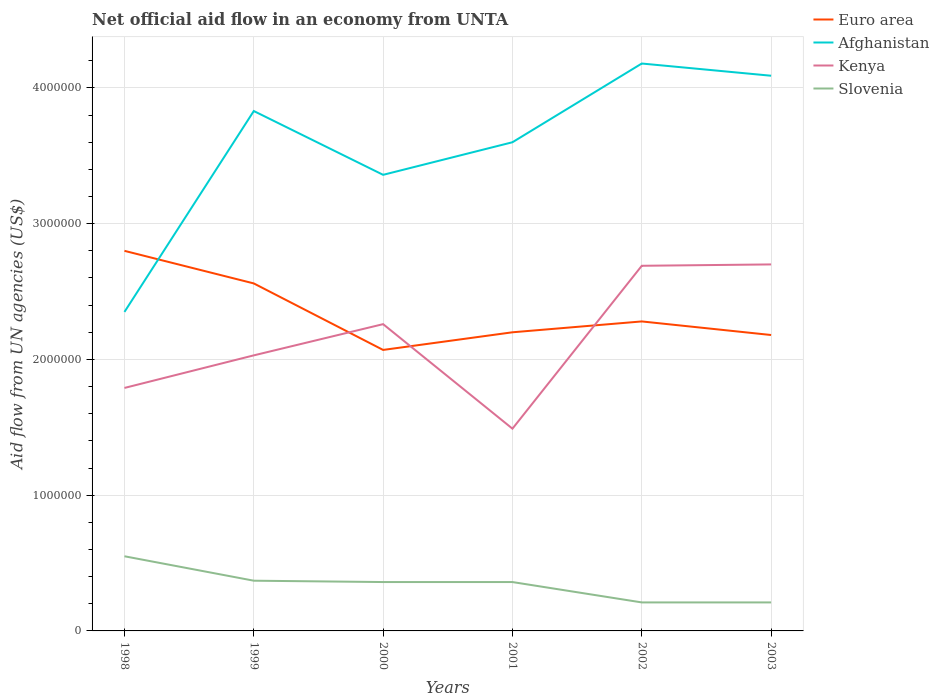How many different coloured lines are there?
Offer a terse response. 4. Is the number of lines equal to the number of legend labels?
Your answer should be very brief. Yes. Across all years, what is the maximum net official aid flow in Afghanistan?
Your answer should be compact. 2.35e+06. In which year was the net official aid flow in Afghanistan maximum?
Offer a very short reply. 1998. What is the difference between the highest and the second highest net official aid flow in Euro area?
Your answer should be compact. 7.30e+05. What is the difference between the highest and the lowest net official aid flow in Slovenia?
Your answer should be compact. 4. How many lines are there?
Make the answer very short. 4. What is the difference between two consecutive major ticks on the Y-axis?
Your answer should be very brief. 1.00e+06. Are the values on the major ticks of Y-axis written in scientific E-notation?
Ensure brevity in your answer.  No. Where does the legend appear in the graph?
Offer a terse response. Top right. How are the legend labels stacked?
Ensure brevity in your answer.  Vertical. What is the title of the graph?
Your response must be concise. Net official aid flow in an economy from UNTA. Does "Lesotho" appear as one of the legend labels in the graph?
Keep it short and to the point. No. What is the label or title of the X-axis?
Ensure brevity in your answer.  Years. What is the label or title of the Y-axis?
Provide a succinct answer. Aid flow from UN agencies (US$). What is the Aid flow from UN agencies (US$) in Euro area in 1998?
Keep it short and to the point. 2.80e+06. What is the Aid flow from UN agencies (US$) of Afghanistan in 1998?
Ensure brevity in your answer.  2.35e+06. What is the Aid flow from UN agencies (US$) of Kenya in 1998?
Your answer should be compact. 1.79e+06. What is the Aid flow from UN agencies (US$) of Euro area in 1999?
Ensure brevity in your answer.  2.56e+06. What is the Aid flow from UN agencies (US$) in Afghanistan in 1999?
Give a very brief answer. 3.83e+06. What is the Aid flow from UN agencies (US$) of Kenya in 1999?
Offer a terse response. 2.03e+06. What is the Aid flow from UN agencies (US$) of Euro area in 2000?
Ensure brevity in your answer.  2.07e+06. What is the Aid flow from UN agencies (US$) of Afghanistan in 2000?
Your response must be concise. 3.36e+06. What is the Aid flow from UN agencies (US$) in Kenya in 2000?
Your response must be concise. 2.26e+06. What is the Aid flow from UN agencies (US$) in Euro area in 2001?
Your answer should be compact. 2.20e+06. What is the Aid flow from UN agencies (US$) in Afghanistan in 2001?
Ensure brevity in your answer.  3.60e+06. What is the Aid flow from UN agencies (US$) of Kenya in 2001?
Offer a terse response. 1.49e+06. What is the Aid flow from UN agencies (US$) of Slovenia in 2001?
Ensure brevity in your answer.  3.60e+05. What is the Aid flow from UN agencies (US$) in Euro area in 2002?
Your answer should be very brief. 2.28e+06. What is the Aid flow from UN agencies (US$) of Afghanistan in 2002?
Ensure brevity in your answer.  4.18e+06. What is the Aid flow from UN agencies (US$) in Kenya in 2002?
Offer a terse response. 2.69e+06. What is the Aid flow from UN agencies (US$) of Slovenia in 2002?
Give a very brief answer. 2.10e+05. What is the Aid flow from UN agencies (US$) of Euro area in 2003?
Offer a terse response. 2.18e+06. What is the Aid flow from UN agencies (US$) in Afghanistan in 2003?
Your answer should be very brief. 4.09e+06. What is the Aid flow from UN agencies (US$) of Kenya in 2003?
Your answer should be very brief. 2.70e+06. Across all years, what is the maximum Aid flow from UN agencies (US$) in Euro area?
Give a very brief answer. 2.80e+06. Across all years, what is the maximum Aid flow from UN agencies (US$) of Afghanistan?
Make the answer very short. 4.18e+06. Across all years, what is the maximum Aid flow from UN agencies (US$) in Kenya?
Offer a very short reply. 2.70e+06. Across all years, what is the maximum Aid flow from UN agencies (US$) in Slovenia?
Provide a short and direct response. 5.50e+05. Across all years, what is the minimum Aid flow from UN agencies (US$) of Euro area?
Offer a very short reply. 2.07e+06. Across all years, what is the minimum Aid flow from UN agencies (US$) of Afghanistan?
Provide a short and direct response. 2.35e+06. Across all years, what is the minimum Aid flow from UN agencies (US$) in Kenya?
Provide a short and direct response. 1.49e+06. Across all years, what is the minimum Aid flow from UN agencies (US$) in Slovenia?
Your answer should be very brief. 2.10e+05. What is the total Aid flow from UN agencies (US$) in Euro area in the graph?
Your answer should be very brief. 1.41e+07. What is the total Aid flow from UN agencies (US$) in Afghanistan in the graph?
Your answer should be compact. 2.14e+07. What is the total Aid flow from UN agencies (US$) of Kenya in the graph?
Keep it short and to the point. 1.30e+07. What is the total Aid flow from UN agencies (US$) in Slovenia in the graph?
Give a very brief answer. 2.06e+06. What is the difference between the Aid flow from UN agencies (US$) of Afghanistan in 1998 and that in 1999?
Offer a terse response. -1.48e+06. What is the difference between the Aid flow from UN agencies (US$) in Euro area in 1998 and that in 2000?
Offer a terse response. 7.30e+05. What is the difference between the Aid flow from UN agencies (US$) of Afghanistan in 1998 and that in 2000?
Provide a short and direct response. -1.01e+06. What is the difference between the Aid flow from UN agencies (US$) of Kenya in 1998 and that in 2000?
Give a very brief answer. -4.70e+05. What is the difference between the Aid flow from UN agencies (US$) in Slovenia in 1998 and that in 2000?
Give a very brief answer. 1.90e+05. What is the difference between the Aid flow from UN agencies (US$) in Afghanistan in 1998 and that in 2001?
Ensure brevity in your answer.  -1.25e+06. What is the difference between the Aid flow from UN agencies (US$) in Kenya in 1998 and that in 2001?
Provide a short and direct response. 3.00e+05. What is the difference between the Aid flow from UN agencies (US$) of Slovenia in 1998 and that in 2001?
Make the answer very short. 1.90e+05. What is the difference between the Aid flow from UN agencies (US$) of Euro area in 1998 and that in 2002?
Ensure brevity in your answer.  5.20e+05. What is the difference between the Aid flow from UN agencies (US$) in Afghanistan in 1998 and that in 2002?
Provide a succinct answer. -1.83e+06. What is the difference between the Aid flow from UN agencies (US$) of Kenya in 1998 and that in 2002?
Provide a succinct answer. -9.00e+05. What is the difference between the Aid flow from UN agencies (US$) of Euro area in 1998 and that in 2003?
Offer a terse response. 6.20e+05. What is the difference between the Aid flow from UN agencies (US$) of Afghanistan in 1998 and that in 2003?
Make the answer very short. -1.74e+06. What is the difference between the Aid flow from UN agencies (US$) of Kenya in 1998 and that in 2003?
Offer a very short reply. -9.10e+05. What is the difference between the Aid flow from UN agencies (US$) of Slovenia in 1999 and that in 2000?
Keep it short and to the point. 10000. What is the difference between the Aid flow from UN agencies (US$) in Afghanistan in 1999 and that in 2001?
Offer a terse response. 2.30e+05. What is the difference between the Aid flow from UN agencies (US$) in Kenya in 1999 and that in 2001?
Provide a succinct answer. 5.40e+05. What is the difference between the Aid flow from UN agencies (US$) in Afghanistan in 1999 and that in 2002?
Provide a short and direct response. -3.50e+05. What is the difference between the Aid flow from UN agencies (US$) in Kenya in 1999 and that in 2002?
Keep it short and to the point. -6.60e+05. What is the difference between the Aid flow from UN agencies (US$) in Slovenia in 1999 and that in 2002?
Offer a very short reply. 1.60e+05. What is the difference between the Aid flow from UN agencies (US$) of Euro area in 1999 and that in 2003?
Your answer should be very brief. 3.80e+05. What is the difference between the Aid flow from UN agencies (US$) of Afghanistan in 1999 and that in 2003?
Ensure brevity in your answer.  -2.60e+05. What is the difference between the Aid flow from UN agencies (US$) in Kenya in 1999 and that in 2003?
Ensure brevity in your answer.  -6.70e+05. What is the difference between the Aid flow from UN agencies (US$) in Slovenia in 1999 and that in 2003?
Your answer should be compact. 1.60e+05. What is the difference between the Aid flow from UN agencies (US$) of Afghanistan in 2000 and that in 2001?
Provide a succinct answer. -2.40e+05. What is the difference between the Aid flow from UN agencies (US$) of Kenya in 2000 and that in 2001?
Make the answer very short. 7.70e+05. What is the difference between the Aid flow from UN agencies (US$) in Afghanistan in 2000 and that in 2002?
Provide a short and direct response. -8.20e+05. What is the difference between the Aid flow from UN agencies (US$) of Kenya in 2000 and that in 2002?
Your answer should be very brief. -4.30e+05. What is the difference between the Aid flow from UN agencies (US$) of Slovenia in 2000 and that in 2002?
Your answer should be compact. 1.50e+05. What is the difference between the Aid flow from UN agencies (US$) in Euro area in 2000 and that in 2003?
Provide a succinct answer. -1.10e+05. What is the difference between the Aid flow from UN agencies (US$) of Afghanistan in 2000 and that in 2003?
Ensure brevity in your answer.  -7.30e+05. What is the difference between the Aid flow from UN agencies (US$) in Kenya in 2000 and that in 2003?
Provide a succinct answer. -4.40e+05. What is the difference between the Aid flow from UN agencies (US$) of Slovenia in 2000 and that in 2003?
Keep it short and to the point. 1.50e+05. What is the difference between the Aid flow from UN agencies (US$) in Afghanistan in 2001 and that in 2002?
Provide a short and direct response. -5.80e+05. What is the difference between the Aid flow from UN agencies (US$) in Kenya in 2001 and that in 2002?
Your answer should be compact. -1.20e+06. What is the difference between the Aid flow from UN agencies (US$) in Slovenia in 2001 and that in 2002?
Keep it short and to the point. 1.50e+05. What is the difference between the Aid flow from UN agencies (US$) in Euro area in 2001 and that in 2003?
Your answer should be very brief. 2.00e+04. What is the difference between the Aid flow from UN agencies (US$) of Afghanistan in 2001 and that in 2003?
Your answer should be compact. -4.90e+05. What is the difference between the Aid flow from UN agencies (US$) of Kenya in 2001 and that in 2003?
Give a very brief answer. -1.21e+06. What is the difference between the Aid flow from UN agencies (US$) in Slovenia in 2002 and that in 2003?
Your response must be concise. 0. What is the difference between the Aid flow from UN agencies (US$) in Euro area in 1998 and the Aid flow from UN agencies (US$) in Afghanistan in 1999?
Your response must be concise. -1.03e+06. What is the difference between the Aid flow from UN agencies (US$) in Euro area in 1998 and the Aid flow from UN agencies (US$) in Kenya in 1999?
Ensure brevity in your answer.  7.70e+05. What is the difference between the Aid flow from UN agencies (US$) of Euro area in 1998 and the Aid flow from UN agencies (US$) of Slovenia in 1999?
Offer a very short reply. 2.43e+06. What is the difference between the Aid flow from UN agencies (US$) of Afghanistan in 1998 and the Aid flow from UN agencies (US$) of Kenya in 1999?
Give a very brief answer. 3.20e+05. What is the difference between the Aid flow from UN agencies (US$) in Afghanistan in 1998 and the Aid flow from UN agencies (US$) in Slovenia in 1999?
Your answer should be compact. 1.98e+06. What is the difference between the Aid flow from UN agencies (US$) of Kenya in 1998 and the Aid flow from UN agencies (US$) of Slovenia in 1999?
Make the answer very short. 1.42e+06. What is the difference between the Aid flow from UN agencies (US$) of Euro area in 1998 and the Aid flow from UN agencies (US$) of Afghanistan in 2000?
Your answer should be compact. -5.60e+05. What is the difference between the Aid flow from UN agencies (US$) in Euro area in 1998 and the Aid flow from UN agencies (US$) in Kenya in 2000?
Provide a succinct answer. 5.40e+05. What is the difference between the Aid flow from UN agencies (US$) in Euro area in 1998 and the Aid flow from UN agencies (US$) in Slovenia in 2000?
Provide a succinct answer. 2.44e+06. What is the difference between the Aid flow from UN agencies (US$) in Afghanistan in 1998 and the Aid flow from UN agencies (US$) in Slovenia in 2000?
Provide a succinct answer. 1.99e+06. What is the difference between the Aid flow from UN agencies (US$) of Kenya in 1998 and the Aid flow from UN agencies (US$) of Slovenia in 2000?
Your response must be concise. 1.43e+06. What is the difference between the Aid flow from UN agencies (US$) in Euro area in 1998 and the Aid flow from UN agencies (US$) in Afghanistan in 2001?
Your answer should be compact. -8.00e+05. What is the difference between the Aid flow from UN agencies (US$) in Euro area in 1998 and the Aid flow from UN agencies (US$) in Kenya in 2001?
Offer a terse response. 1.31e+06. What is the difference between the Aid flow from UN agencies (US$) in Euro area in 1998 and the Aid flow from UN agencies (US$) in Slovenia in 2001?
Give a very brief answer. 2.44e+06. What is the difference between the Aid flow from UN agencies (US$) of Afghanistan in 1998 and the Aid flow from UN agencies (US$) of Kenya in 2001?
Your answer should be very brief. 8.60e+05. What is the difference between the Aid flow from UN agencies (US$) in Afghanistan in 1998 and the Aid flow from UN agencies (US$) in Slovenia in 2001?
Your answer should be compact. 1.99e+06. What is the difference between the Aid flow from UN agencies (US$) in Kenya in 1998 and the Aid flow from UN agencies (US$) in Slovenia in 2001?
Keep it short and to the point. 1.43e+06. What is the difference between the Aid flow from UN agencies (US$) of Euro area in 1998 and the Aid flow from UN agencies (US$) of Afghanistan in 2002?
Keep it short and to the point. -1.38e+06. What is the difference between the Aid flow from UN agencies (US$) of Euro area in 1998 and the Aid flow from UN agencies (US$) of Slovenia in 2002?
Ensure brevity in your answer.  2.59e+06. What is the difference between the Aid flow from UN agencies (US$) in Afghanistan in 1998 and the Aid flow from UN agencies (US$) in Kenya in 2002?
Your answer should be very brief. -3.40e+05. What is the difference between the Aid flow from UN agencies (US$) of Afghanistan in 1998 and the Aid flow from UN agencies (US$) of Slovenia in 2002?
Give a very brief answer. 2.14e+06. What is the difference between the Aid flow from UN agencies (US$) in Kenya in 1998 and the Aid flow from UN agencies (US$) in Slovenia in 2002?
Make the answer very short. 1.58e+06. What is the difference between the Aid flow from UN agencies (US$) of Euro area in 1998 and the Aid flow from UN agencies (US$) of Afghanistan in 2003?
Give a very brief answer. -1.29e+06. What is the difference between the Aid flow from UN agencies (US$) in Euro area in 1998 and the Aid flow from UN agencies (US$) in Kenya in 2003?
Ensure brevity in your answer.  1.00e+05. What is the difference between the Aid flow from UN agencies (US$) of Euro area in 1998 and the Aid flow from UN agencies (US$) of Slovenia in 2003?
Keep it short and to the point. 2.59e+06. What is the difference between the Aid flow from UN agencies (US$) of Afghanistan in 1998 and the Aid flow from UN agencies (US$) of Kenya in 2003?
Make the answer very short. -3.50e+05. What is the difference between the Aid flow from UN agencies (US$) of Afghanistan in 1998 and the Aid flow from UN agencies (US$) of Slovenia in 2003?
Offer a terse response. 2.14e+06. What is the difference between the Aid flow from UN agencies (US$) of Kenya in 1998 and the Aid flow from UN agencies (US$) of Slovenia in 2003?
Ensure brevity in your answer.  1.58e+06. What is the difference between the Aid flow from UN agencies (US$) in Euro area in 1999 and the Aid flow from UN agencies (US$) in Afghanistan in 2000?
Provide a short and direct response. -8.00e+05. What is the difference between the Aid flow from UN agencies (US$) in Euro area in 1999 and the Aid flow from UN agencies (US$) in Kenya in 2000?
Your response must be concise. 3.00e+05. What is the difference between the Aid flow from UN agencies (US$) in Euro area in 1999 and the Aid flow from UN agencies (US$) in Slovenia in 2000?
Make the answer very short. 2.20e+06. What is the difference between the Aid flow from UN agencies (US$) of Afghanistan in 1999 and the Aid flow from UN agencies (US$) of Kenya in 2000?
Offer a very short reply. 1.57e+06. What is the difference between the Aid flow from UN agencies (US$) in Afghanistan in 1999 and the Aid flow from UN agencies (US$) in Slovenia in 2000?
Ensure brevity in your answer.  3.47e+06. What is the difference between the Aid flow from UN agencies (US$) of Kenya in 1999 and the Aid flow from UN agencies (US$) of Slovenia in 2000?
Make the answer very short. 1.67e+06. What is the difference between the Aid flow from UN agencies (US$) of Euro area in 1999 and the Aid flow from UN agencies (US$) of Afghanistan in 2001?
Provide a short and direct response. -1.04e+06. What is the difference between the Aid flow from UN agencies (US$) in Euro area in 1999 and the Aid flow from UN agencies (US$) in Kenya in 2001?
Your response must be concise. 1.07e+06. What is the difference between the Aid flow from UN agencies (US$) of Euro area in 1999 and the Aid flow from UN agencies (US$) of Slovenia in 2001?
Your answer should be compact. 2.20e+06. What is the difference between the Aid flow from UN agencies (US$) of Afghanistan in 1999 and the Aid flow from UN agencies (US$) of Kenya in 2001?
Your answer should be compact. 2.34e+06. What is the difference between the Aid flow from UN agencies (US$) of Afghanistan in 1999 and the Aid flow from UN agencies (US$) of Slovenia in 2001?
Make the answer very short. 3.47e+06. What is the difference between the Aid flow from UN agencies (US$) of Kenya in 1999 and the Aid flow from UN agencies (US$) of Slovenia in 2001?
Provide a succinct answer. 1.67e+06. What is the difference between the Aid flow from UN agencies (US$) in Euro area in 1999 and the Aid flow from UN agencies (US$) in Afghanistan in 2002?
Your response must be concise. -1.62e+06. What is the difference between the Aid flow from UN agencies (US$) in Euro area in 1999 and the Aid flow from UN agencies (US$) in Kenya in 2002?
Give a very brief answer. -1.30e+05. What is the difference between the Aid flow from UN agencies (US$) in Euro area in 1999 and the Aid flow from UN agencies (US$) in Slovenia in 2002?
Make the answer very short. 2.35e+06. What is the difference between the Aid flow from UN agencies (US$) of Afghanistan in 1999 and the Aid flow from UN agencies (US$) of Kenya in 2002?
Make the answer very short. 1.14e+06. What is the difference between the Aid flow from UN agencies (US$) in Afghanistan in 1999 and the Aid flow from UN agencies (US$) in Slovenia in 2002?
Provide a succinct answer. 3.62e+06. What is the difference between the Aid flow from UN agencies (US$) in Kenya in 1999 and the Aid flow from UN agencies (US$) in Slovenia in 2002?
Your response must be concise. 1.82e+06. What is the difference between the Aid flow from UN agencies (US$) in Euro area in 1999 and the Aid flow from UN agencies (US$) in Afghanistan in 2003?
Your response must be concise. -1.53e+06. What is the difference between the Aid flow from UN agencies (US$) in Euro area in 1999 and the Aid flow from UN agencies (US$) in Slovenia in 2003?
Give a very brief answer. 2.35e+06. What is the difference between the Aid flow from UN agencies (US$) in Afghanistan in 1999 and the Aid flow from UN agencies (US$) in Kenya in 2003?
Offer a very short reply. 1.13e+06. What is the difference between the Aid flow from UN agencies (US$) of Afghanistan in 1999 and the Aid flow from UN agencies (US$) of Slovenia in 2003?
Offer a terse response. 3.62e+06. What is the difference between the Aid flow from UN agencies (US$) in Kenya in 1999 and the Aid flow from UN agencies (US$) in Slovenia in 2003?
Make the answer very short. 1.82e+06. What is the difference between the Aid flow from UN agencies (US$) in Euro area in 2000 and the Aid flow from UN agencies (US$) in Afghanistan in 2001?
Keep it short and to the point. -1.53e+06. What is the difference between the Aid flow from UN agencies (US$) in Euro area in 2000 and the Aid flow from UN agencies (US$) in Kenya in 2001?
Your answer should be compact. 5.80e+05. What is the difference between the Aid flow from UN agencies (US$) of Euro area in 2000 and the Aid flow from UN agencies (US$) of Slovenia in 2001?
Offer a terse response. 1.71e+06. What is the difference between the Aid flow from UN agencies (US$) of Afghanistan in 2000 and the Aid flow from UN agencies (US$) of Kenya in 2001?
Provide a succinct answer. 1.87e+06. What is the difference between the Aid flow from UN agencies (US$) in Kenya in 2000 and the Aid flow from UN agencies (US$) in Slovenia in 2001?
Make the answer very short. 1.90e+06. What is the difference between the Aid flow from UN agencies (US$) in Euro area in 2000 and the Aid flow from UN agencies (US$) in Afghanistan in 2002?
Ensure brevity in your answer.  -2.11e+06. What is the difference between the Aid flow from UN agencies (US$) in Euro area in 2000 and the Aid flow from UN agencies (US$) in Kenya in 2002?
Your response must be concise. -6.20e+05. What is the difference between the Aid flow from UN agencies (US$) in Euro area in 2000 and the Aid flow from UN agencies (US$) in Slovenia in 2002?
Your answer should be very brief. 1.86e+06. What is the difference between the Aid flow from UN agencies (US$) of Afghanistan in 2000 and the Aid flow from UN agencies (US$) of Kenya in 2002?
Make the answer very short. 6.70e+05. What is the difference between the Aid flow from UN agencies (US$) of Afghanistan in 2000 and the Aid flow from UN agencies (US$) of Slovenia in 2002?
Make the answer very short. 3.15e+06. What is the difference between the Aid flow from UN agencies (US$) in Kenya in 2000 and the Aid flow from UN agencies (US$) in Slovenia in 2002?
Make the answer very short. 2.05e+06. What is the difference between the Aid flow from UN agencies (US$) of Euro area in 2000 and the Aid flow from UN agencies (US$) of Afghanistan in 2003?
Provide a short and direct response. -2.02e+06. What is the difference between the Aid flow from UN agencies (US$) in Euro area in 2000 and the Aid flow from UN agencies (US$) in Kenya in 2003?
Offer a terse response. -6.30e+05. What is the difference between the Aid flow from UN agencies (US$) in Euro area in 2000 and the Aid flow from UN agencies (US$) in Slovenia in 2003?
Keep it short and to the point. 1.86e+06. What is the difference between the Aid flow from UN agencies (US$) in Afghanistan in 2000 and the Aid flow from UN agencies (US$) in Kenya in 2003?
Give a very brief answer. 6.60e+05. What is the difference between the Aid flow from UN agencies (US$) in Afghanistan in 2000 and the Aid flow from UN agencies (US$) in Slovenia in 2003?
Your response must be concise. 3.15e+06. What is the difference between the Aid flow from UN agencies (US$) in Kenya in 2000 and the Aid flow from UN agencies (US$) in Slovenia in 2003?
Give a very brief answer. 2.05e+06. What is the difference between the Aid flow from UN agencies (US$) in Euro area in 2001 and the Aid flow from UN agencies (US$) in Afghanistan in 2002?
Ensure brevity in your answer.  -1.98e+06. What is the difference between the Aid flow from UN agencies (US$) of Euro area in 2001 and the Aid flow from UN agencies (US$) of Kenya in 2002?
Your answer should be compact. -4.90e+05. What is the difference between the Aid flow from UN agencies (US$) in Euro area in 2001 and the Aid flow from UN agencies (US$) in Slovenia in 2002?
Provide a short and direct response. 1.99e+06. What is the difference between the Aid flow from UN agencies (US$) in Afghanistan in 2001 and the Aid flow from UN agencies (US$) in Kenya in 2002?
Your response must be concise. 9.10e+05. What is the difference between the Aid flow from UN agencies (US$) in Afghanistan in 2001 and the Aid flow from UN agencies (US$) in Slovenia in 2002?
Give a very brief answer. 3.39e+06. What is the difference between the Aid flow from UN agencies (US$) of Kenya in 2001 and the Aid flow from UN agencies (US$) of Slovenia in 2002?
Offer a terse response. 1.28e+06. What is the difference between the Aid flow from UN agencies (US$) in Euro area in 2001 and the Aid flow from UN agencies (US$) in Afghanistan in 2003?
Your response must be concise. -1.89e+06. What is the difference between the Aid flow from UN agencies (US$) of Euro area in 2001 and the Aid flow from UN agencies (US$) of Kenya in 2003?
Keep it short and to the point. -5.00e+05. What is the difference between the Aid flow from UN agencies (US$) of Euro area in 2001 and the Aid flow from UN agencies (US$) of Slovenia in 2003?
Offer a very short reply. 1.99e+06. What is the difference between the Aid flow from UN agencies (US$) of Afghanistan in 2001 and the Aid flow from UN agencies (US$) of Kenya in 2003?
Your answer should be very brief. 9.00e+05. What is the difference between the Aid flow from UN agencies (US$) of Afghanistan in 2001 and the Aid flow from UN agencies (US$) of Slovenia in 2003?
Your answer should be compact. 3.39e+06. What is the difference between the Aid flow from UN agencies (US$) of Kenya in 2001 and the Aid flow from UN agencies (US$) of Slovenia in 2003?
Keep it short and to the point. 1.28e+06. What is the difference between the Aid flow from UN agencies (US$) in Euro area in 2002 and the Aid flow from UN agencies (US$) in Afghanistan in 2003?
Your answer should be compact. -1.81e+06. What is the difference between the Aid flow from UN agencies (US$) in Euro area in 2002 and the Aid flow from UN agencies (US$) in Kenya in 2003?
Give a very brief answer. -4.20e+05. What is the difference between the Aid flow from UN agencies (US$) of Euro area in 2002 and the Aid flow from UN agencies (US$) of Slovenia in 2003?
Provide a succinct answer. 2.07e+06. What is the difference between the Aid flow from UN agencies (US$) of Afghanistan in 2002 and the Aid flow from UN agencies (US$) of Kenya in 2003?
Offer a very short reply. 1.48e+06. What is the difference between the Aid flow from UN agencies (US$) in Afghanistan in 2002 and the Aid flow from UN agencies (US$) in Slovenia in 2003?
Offer a very short reply. 3.97e+06. What is the difference between the Aid flow from UN agencies (US$) of Kenya in 2002 and the Aid flow from UN agencies (US$) of Slovenia in 2003?
Offer a terse response. 2.48e+06. What is the average Aid flow from UN agencies (US$) in Euro area per year?
Your answer should be very brief. 2.35e+06. What is the average Aid flow from UN agencies (US$) in Afghanistan per year?
Provide a short and direct response. 3.57e+06. What is the average Aid flow from UN agencies (US$) of Kenya per year?
Ensure brevity in your answer.  2.16e+06. What is the average Aid flow from UN agencies (US$) in Slovenia per year?
Keep it short and to the point. 3.43e+05. In the year 1998, what is the difference between the Aid flow from UN agencies (US$) of Euro area and Aid flow from UN agencies (US$) of Afghanistan?
Your response must be concise. 4.50e+05. In the year 1998, what is the difference between the Aid flow from UN agencies (US$) of Euro area and Aid flow from UN agencies (US$) of Kenya?
Provide a succinct answer. 1.01e+06. In the year 1998, what is the difference between the Aid flow from UN agencies (US$) of Euro area and Aid flow from UN agencies (US$) of Slovenia?
Ensure brevity in your answer.  2.25e+06. In the year 1998, what is the difference between the Aid flow from UN agencies (US$) of Afghanistan and Aid flow from UN agencies (US$) of Kenya?
Provide a short and direct response. 5.60e+05. In the year 1998, what is the difference between the Aid flow from UN agencies (US$) in Afghanistan and Aid flow from UN agencies (US$) in Slovenia?
Keep it short and to the point. 1.80e+06. In the year 1998, what is the difference between the Aid flow from UN agencies (US$) in Kenya and Aid flow from UN agencies (US$) in Slovenia?
Provide a succinct answer. 1.24e+06. In the year 1999, what is the difference between the Aid flow from UN agencies (US$) in Euro area and Aid flow from UN agencies (US$) in Afghanistan?
Provide a succinct answer. -1.27e+06. In the year 1999, what is the difference between the Aid flow from UN agencies (US$) of Euro area and Aid flow from UN agencies (US$) of Kenya?
Keep it short and to the point. 5.30e+05. In the year 1999, what is the difference between the Aid flow from UN agencies (US$) in Euro area and Aid flow from UN agencies (US$) in Slovenia?
Offer a terse response. 2.19e+06. In the year 1999, what is the difference between the Aid flow from UN agencies (US$) of Afghanistan and Aid flow from UN agencies (US$) of Kenya?
Give a very brief answer. 1.80e+06. In the year 1999, what is the difference between the Aid flow from UN agencies (US$) in Afghanistan and Aid flow from UN agencies (US$) in Slovenia?
Give a very brief answer. 3.46e+06. In the year 1999, what is the difference between the Aid flow from UN agencies (US$) in Kenya and Aid flow from UN agencies (US$) in Slovenia?
Your answer should be very brief. 1.66e+06. In the year 2000, what is the difference between the Aid flow from UN agencies (US$) in Euro area and Aid flow from UN agencies (US$) in Afghanistan?
Offer a very short reply. -1.29e+06. In the year 2000, what is the difference between the Aid flow from UN agencies (US$) in Euro area and Aid flow from UN agencies (US$) in Slovenia?
Make the answer very short. 1.71e+06. In the year 2000, what is the difference between the Aid flow from UN agencies (US$) of Afghanistan and Aid flow from UN agencies (US$) of Kenya?
Provide a succinct answer. 1.10e+06. In the year 2000, what is the difference between the Aid flow from UN agencies (US$) in Kenya and Aid flow from UN agencies (US$) in Slovenia?
Offer a very short reply. 1.90e+06. In the year 2001, what is the difference between the Aid flow from UN agencies (US$) of Euro area and Aid flow from UN agencies (US$) of Afghanistan?
Your response must be concise. -1.40e+06. In the year 2001, what is the difference between the Aid flow from UN agencies (US$) of Euro area and Aid flow from UN agencies (US$) of Kenya?
Keep it short and to the point. 7.10e+05. In the year 2001, what is the difference between the Aid flow from UN agencies (US$) of Euro area and Aid flow from UN agencies (US$) of Slovenia?
Ensure brevity in your answer.  1.84e+06. In the year 2001, what is the difference between the Aid flow from UN agencies (US$) in Afghanistan and Aid flow from UN agencies (US$) in Kenya?
Your answer should be very brief. 2.11e+06. In the year 2001, what is the difference between the Aid flow from UN agencies (US$) in Afghanistan and Aid flow from UN agencies (US$) in Slovenia?
Provide a succinct answer. 3.24e+06. In the year 2001, what is the difference between the Aid flow from UN agencies (US$) in Kenya and Aid flow from UN agencies (US$) in Slovenia?
Provide a succinct answer. 1.13e+06. In the year 2002, what is the difference between the Aid flow from UN agencies (US$) in Euro area and Aid flow from UN agencies (US$) in Afghanistan?
Make the answer very short. -1.90e+06. In the year 2002, what is the difference between the Aid flow from UN agencies (US$) in Euro area and Aid flow from UN agencies (US$) in Kenya?
Give a very brief answer. -4.10e+05. In the year 2002, what is the difference between the Aid flow from UN agencies (US$) in Euro area and Aid flow from UN agencies (US$) in Slovenia?
Make the answer very short. 2.07e+06. In the year 2002, what is the difference between the Aid flow from UN agencies (US$) of Afghanistan and Aid flow from UN agencies (US$) of Kenya?
Offer a terse response. 1.49e+06. In the year 2002, what is the difference between the Aid flow from UN agencies (US$) in Afghanistan and Aid flow from UN agencies (US$) in Slovenia?
Keep it short and to the point. 3.97e+06. In the year 2002, what is the difference between the Aid flow from UN agencies (US$) in Kenya and Aid flow from UN agencies (US$) in Slovenia?
Your response must be concise. 2.48e+06. In the year 2003, what is the difference between the Aid flow from UN agencies (US$) in Euro area and Aid flow from UN agencies (US$) in Afghanistan?
Offer a terse response. -1.91e+06. In the year 2003, what is the difference between the Aid flow from UN agencies (US$) of Euro area and Aid flow from UN agencies (US$) of Kenya?
Make the answer very short. -5.20e+05. In the year 2003, what is the difference between the Aid flow from UN agencies (US$) in Euro area and Aid flow from UN agencies (US$) in Slovenia?
Give a very brief answer. 1.97e+06. In the year 2003, what is the difference between the Aid flow from UN agencies (US$) of Afghanistan and Aid flow from UN agencies (US$) of Kenya?
Offer a terse response. 1.39e+06. In the year 2003, what is the difference between the Aid flow from UN agencies (US$) of Afghanistan and Aid flow from UN agencies (US$) of Slovenia?
Your answer should be compact. 3.88e+06. In the year 2003, what is the difference between the Aid flow from UN agencies (US$) in Kenya and Aid flow from UN agencies (US$) in Slovenia?
Your response must be concise. 2.49e+06. What is the ratio of the Aid flow from UN agencies (US$) in Euro area in 1998 to that in 1999?
Your answer should be compact. 1.09. What is the ratio of the Aid flow from UN agencies (US$) of Afghanistan in 1998 to that in 1999?
Offer a very short reply. 0.61. What is the ratio of the Aid flow from UN agencies (US$) of Kenya in 1998 to that in 1999?
Provide a succinct answer. 0.88. What is the ratio of the Aid flow from UN agencies (US$) of Slovenia in 1998 to that in 1999?
Offer a terse response. 1.49. What is the ratio of the Aid flow from UN agencies (US$) of Euro area in 1998 to that in 2000?
Ensure brevity in your answer.  1.35. What is the ratio of the Aid flow from UN agencies (US$) in Afghanistan in 1998 to that in 2000?
Provide a short and direct response. 0.7. What is the ratio of the Aid flow from UN agencies (US$) of Kenya in 1998 to that in 2000?
Offer a terse response. 0.79. What is the ratio of the Aid flow from UN agencies (US$) in Slovenia in 1998 to that in 2000?
Ensure brevity in your answer.  1.53. What is the ratio of the Aid flow from UN agencies (US$) in Euro area in 1998 to that in 2001?
Offer a very short reply. 1.27. What is the ratio of the Aid flow from UN agencies (US$) in Afghanistan in 1998 to that in 2001?
Ensure brevity in your answer.  0.65. What is the ratio of the Aid flow from UN agencies (US$) in Kenya in 1998 to that in 2001?
Offer a terse response. 1.2. What is the ratio of the Aid flow from UN agencies (US$) of Slovenia in 1998 to that in 2001?
Offer a terse response. 1.53. What is the ratio of the Aid flow from UN agencies (US$) of Euro area in 1998 to that in 2002?
Your response must be concise. 1.23. What is the ratio of the Aid flow from UN agencies (US$) in Afghanistan in 1998 to that in 2002?
Give a very brief answer. 0.56. What is the ratio of the Aid flow from UN agencies (US$) of Kenya in 1998 to that in 2002?
Offer a very short reply. 0.67. What is the ratio of the Aid flow from UN agencies (US$) in Slovenia in 1998 to that in 2002?
Offer a very short reply. 2.62. What is the ratio of the Aid flow from UN agencies (US$) in Euro area in 1998 to that in 2003?
Provide a succinct answer. 1.28. What is the ratio of the Aid flow from UN agencies (US$) of Afghanistan in 1998 to that in 2003?
Your answer should be compact. 0.57. What is the ratio of the Aid flow from UN agencies (US$) in Kenya in 1998 to that in 2003?
Provide a short and direct response. 0.66. What is the ratio of the Aid flow from UN agencies (US$) of Slovenia in 1998 to that in 2003?
Your answer should be very brief. 2.62. What is the ratio of the Aid flow from UN agencies (US$) in Euro area in 1999 to that in 2000?
Make the answer very short. 1.24. What is the ratio of the Aid flow from UN agencies (US$) in Afghanistan in 1999 to that in 2000?
Offer a terse response. 1.14. What is the ratio of the Aid flow from UN agencies (US$) of Kenya in 1999 to that in 2000?
Make the answer very short. 0.9. What is the ratio of the Aid flow from UN agencies (US$) in Slovenia in 1999 to that in 2000?
Provide a succinct answer. 1.03. What is the ratio of the Aid flow from UN agencies (US$) in Euro area in 1999 to that in 2001?
Offer a terse response. 1.16. What is the ratio of the Aid flow from UN agencies (US$) of Afghanistan in 1999 to that in 2001?
Keep it short and to the point. 1.06. What is the ratio of the Aid flow from UN agencies (US$) in Kenya in 1999 to that in 2001?
Give a very brief answer. 1.36. What is the ratio of the Aid flow from UN agencies (US$) in Slovenia in 1999 to that in 2001?
Give a very brief answer. 1.03. What is the ratio of the Aid flow from UN agencies (US$) in Euro area in 1999 to that in 2002?
Ensure brevity in your answer.  1.12. What is the ratio of the Aid flow from UN agencies (US$) in Afghanistan in 1999 to that in 2002?
Offer a terse response. 0.92. What is the ratio of the Aid flow from UN agencies (US$) in Kenya in 1999 to that in 2002?
Provide a succinct answer. 0.75. What is the ratio of the Aid flow from UN agencies (US$) in Slovenia in 1999 to that in 2002?
Provide a short and direct response. 1.76. What is the ratio of the Aid flow from UN agencies (US$) of Euro area in 1999 to that in 2003?
Ensure brevity in your answer.  1.17. What is the ratio of the Aid flow from UN agencies (US$) of Afghanistan in 1999 to that in 2003?
Your answer should be compact. 0.94. What is the ratio of the Aid flow from UN agencies (US$) of Kenya in 1999 to that in 2003?
Your answer should be compact. 0.75. What is the ratio of the Aid flow from UN agencies (US$) in Slovenia in 1999 to that in 2003?
Give a very brief answer. 1.76. What is the ratio of the Aid flow from UN agencies (US$) in Euro area in 2000 to that in 2001?
Ensure brevity in your answer.  0.94. What is the ratio of the Aid flow from UN agencies (US$) in Kenya in 2000 to that in 2001?
Your answer should be very brief. 1.52. What is the ratio of the Aid flow from UN agencies (US$) of Slovenia in 2000 to that in 2001?
Offer a terse response. 1. What is the ratio of the Aid flow from UN agencies (US$) of Euro area in 2000 to that in 2002?
Give a very brief answer. 0.91. What is the ratio of the Aid flow from UN agencies (US$) of Afghanistan in 2000 to that in 2002?
Your answer should be very brief. 0.8. What is the ratio of the Aid flow from UN agencies (US$) in Kenya in 2000 to that in 2002?
Keep it short and to the point. 0.84. What is the ratio of the Aid flow from UN agencies (US$) of Slovenia in 2000 to that in 2002?
Offer a very short reply. 1.71. What is the ratio of the Aid flow from UN agencies (US$) of Euro area in 2000 to that in 2003?
Your answer should be very brief. 0.95. What is the ratio of the Aid flow from UN agencies (US$) of Afghanistan in 2000 to that in 2003?
Your answer should be compact. 0.82. What is the ratio of the Aid flow from UN agencies (US$) in Kenya in 2000 to that in 2003?
Offer a terse response. 0.84. What is the ratio of the Aid flow from UN agencies (US$) of Slovenia in 2000 to that in 2003?
Your answer should be compact. 1.71. What is the ratio of the Aid flow from UN agencies (US$) of Euro area in 2001 to that in 2002?
Ensure brevity in your answer.  0.96. What is the ratio of the Aid flow from UN agencies (US$) of Afghanistan in 2001 to that in 2002?
Your answer should be compact. 0.86. What is the ratio of the Aid flow from UN agencies (US$) of Kenya in 2001 to that in 2002?
Your answer should be compact. 0.55. What is the ratio of the Aid flow from UN agencies (US$) of Slovenia in 2001 to that in 2002?
Your answer should be very brief. 1.71. What is the ratio of the Aid flow from UN agencies (US$) in Euro area in 2001 to that in 2003?
Offer a very short reply. 1.01. What is the ratio of the Aid flow from UN agencies (US$) in Afghanistan in 2001 to that in 2003?
Ensure brevity in your answer.  0.88. What is the ratio of the Aid flow from UN agencies (US$) of Kenya in 2001 to that in 2003?
Provide a short and direct response. 0.55. What is the ratio of the Aid flow from UN agencies (US$) of Slovenia in 2001 to that in 2003?
Give a very brief answer. 1.71. What is the ratio of the Aid flow from UN agencies (US$) in Euro area in 2002 to that in 2003?
Make the answer very short. 1.05. What is the ratio of the Aid flow from UN agencies (US$) of Kenya in 2002 to that in 2003?
Provide a succinct answer. 1. What is the ratio of the Aid flow from UN agencies (US$) in Slovenia in 2002 to that in 2003?
Your answer should be compact. 1. What is the difference between the highest and the second highest Aid flow from UN agencies (US$) in Kenya?
Provide a short and direct response. 10000. What is the difference between the highest and the second highest Aid flow from UN agencies (US$) of Slovenia?
Provide a succinct answer. 1.80e+05. What is the difference between the highest and the lowest Aid flow from UN agencies (US$) of Euro area?
Your response must be concise. 7.30e+05. What is the difference between the highest and the lowest Aid flow from UN agencies (US$) in Afghanistan?
Make the answer very short. 1.83e+06. What is the difference between the highest and the lowest Aid flow from UN agencies (US$) of Kenya?
Provide a succinct answer. 1.21e+06. 